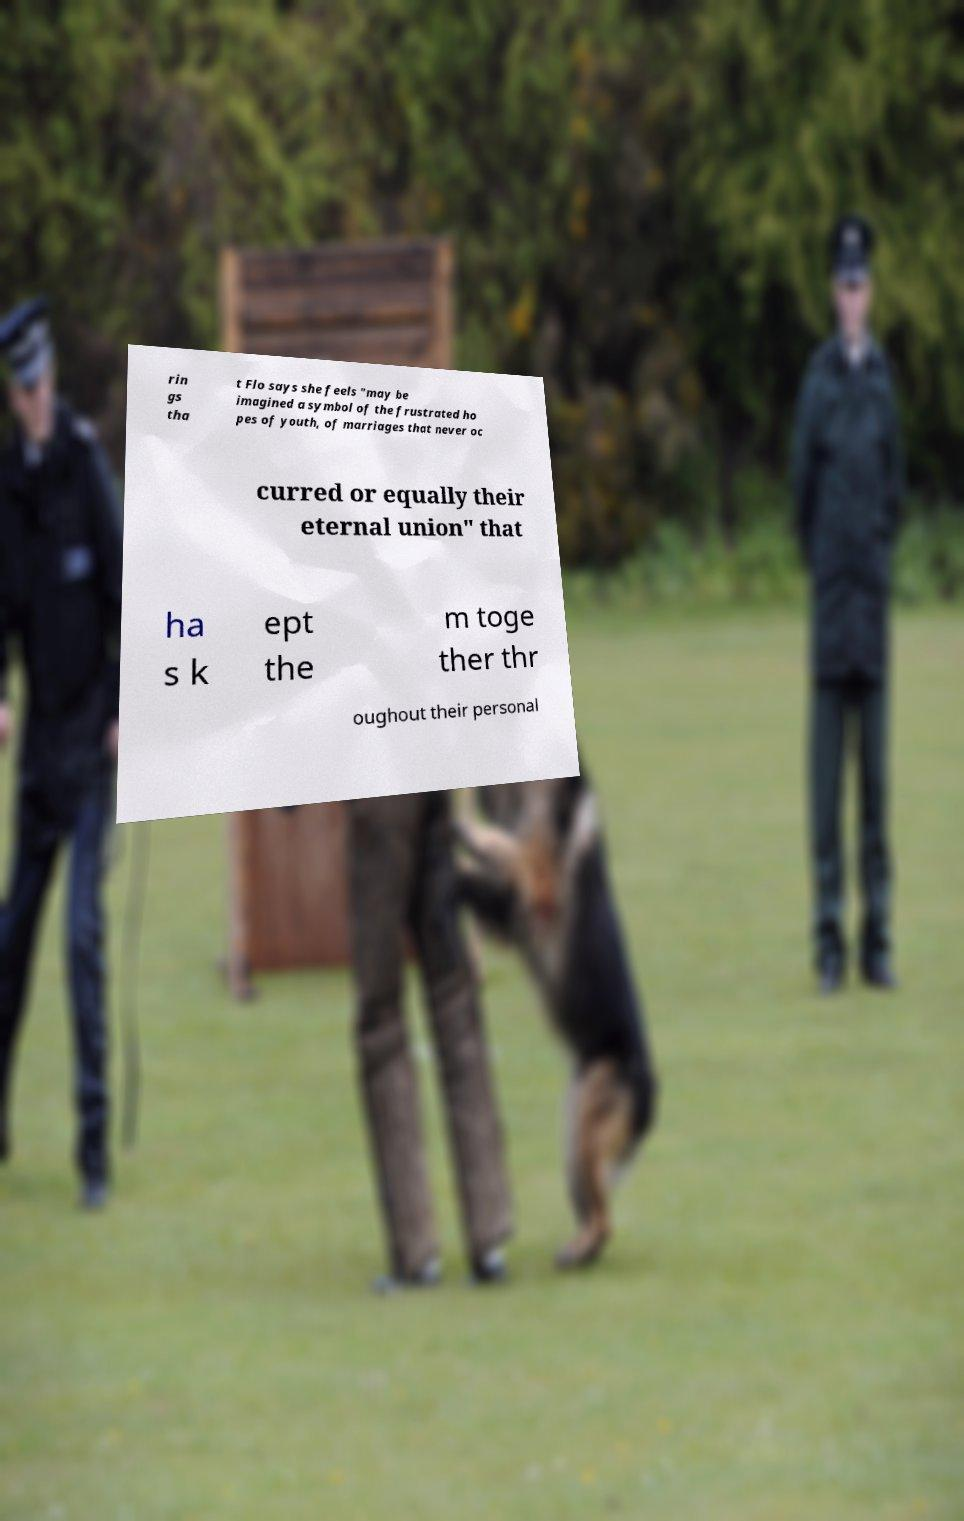For documentation purposes, I need the text within this image transcribed. Could you provide that? rin gs tha t Flo says she feels "may be imagined a symbol of the frustrated ho pes of youth, of marriages that never oc curred or equally their eternal union" that ha s k ept the m toge ther thr oughout their personal 